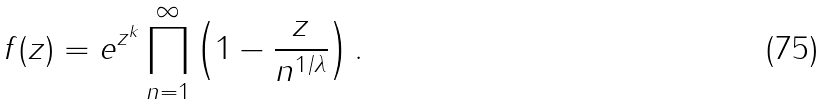Convert formula to latex. <formula><loc_0><loc_0><loc_500><loc_500>f ( z ) = e ^ { z ^ { k } } \prod _ { n = 1 } ^ { \infty } \left ( 1 - \frac { z } { n ^ { 1 / \lambda } } \right ) .</formula> 